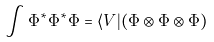<formula> <loc_0><loc_0><loc_500><loc_500>\int \Phi ^ { * } \Phi ^ { * } \Phi = \langle V | ( \Phi \otimes \Phi \otimes \Phi )</formula> 